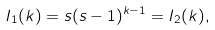Convert formula to latex. <formula><loc_0><loc_0><loc_500><loc_500>I _ { 1 } ( k ) = s ( s - 1 ) ^ { k - 1 } = I _ { 2 } ( k ) ,</formula> 